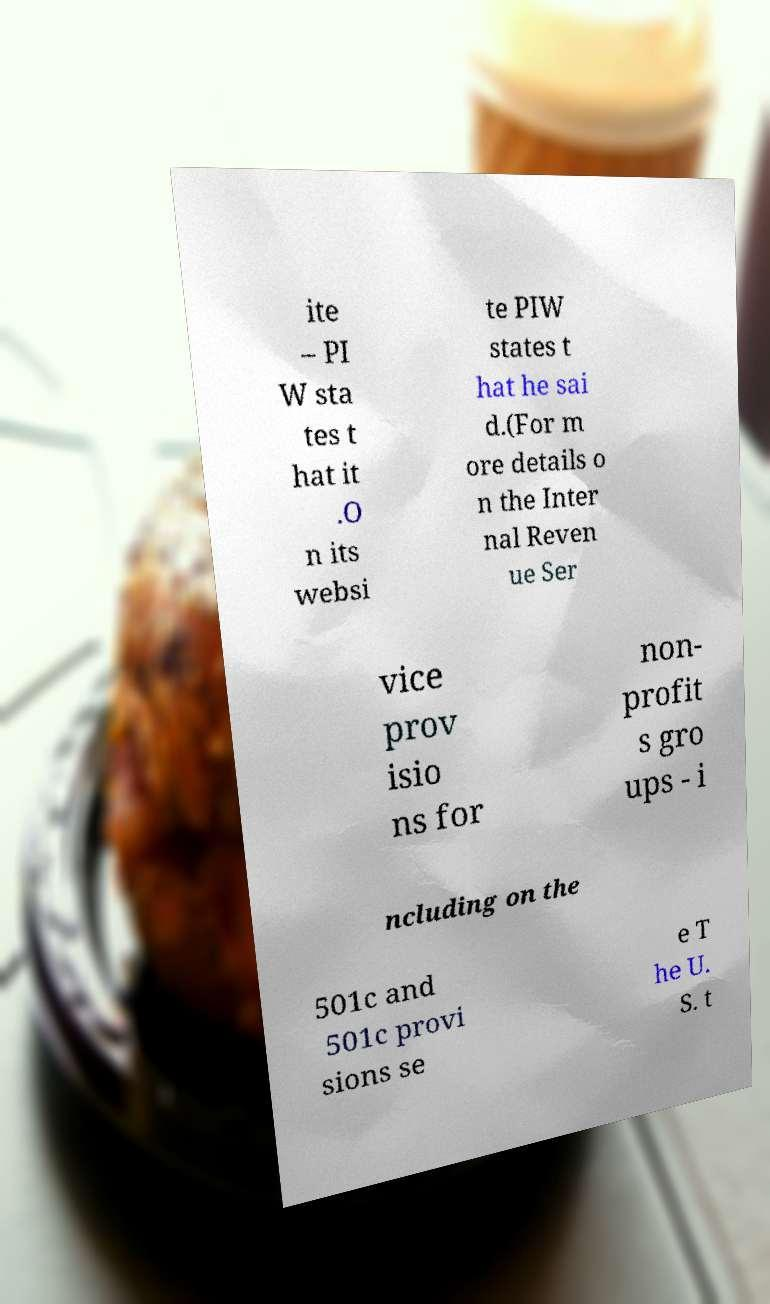Could you extract and type out the text from this image? ite – PI W sta tes t hat it .O n its websi te PIW states t hat he sai d.(For m ore details o n the Inter nal Reven ue Ser vice prov isio ns for non- profit s gro ups - i ncluding on the 501c and 501c provi sions se e T he U. S. t 